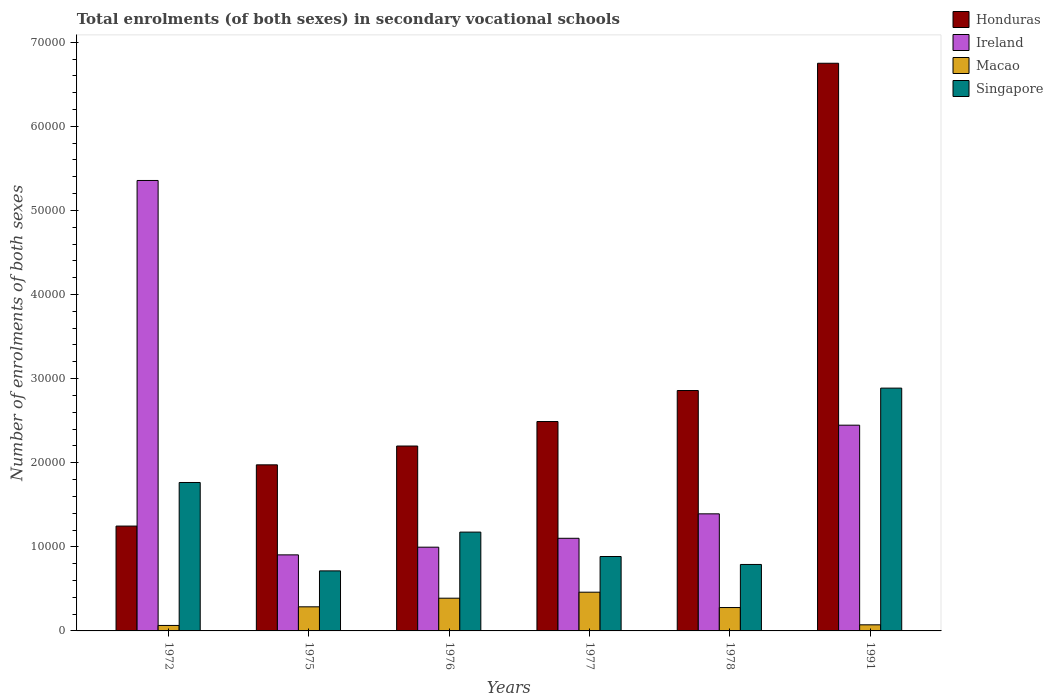How many different coloured bars are there?
Make the answer very short. 4. Are the number of bars per tick equal to the number of legend labels?
Offer a terse response. Yes. Are the number of bars on each tick of the X-axis equal?
Make the answer very short. Yes. How many bars are there on the 4th tick from the right?
Make the answer very short. 4. What is the number of enrolments in secondary schools in Macao in 1976?
Ensure brevity in your answer.  3891. Across all years, what is the maximum number of enrolments in secondary schools in Macao?
Ensure brevity in your answer.  4604. Across all years, what is the minimum number of enrolments in secondary schools in Macao?
Give a very brief answer. 652. In which year was the number of enrolments in secondary schools in Macao maximum?
Your answer should be compact. 1977. What is the total number of enrolments in secondary schools in Macao in the graph?
Offer a very short reply. 1.55e+04. What is the difference between the number of enrolments in secondary schools in Honduras in 1977 and that in 1978?
Provide a succinct answer. -3687. What is the difference between the number of enrolments in secondary schools in Singapore in 1976 and the number of enrolments in secondary schools in Honduras in 1972?
Provide a short and direct response. -717. What is the average number of enrolments in secondary schools in Singapore per year?
Offer a terse response. 1.37e+04. In the year 1975, what is the difference between the number of enrolments in secondary schools in Macao and number of enrolments in secondary schools in Ireland?
Offer a terse response. -6177. In how many years, is the number of enrolments in secondary schools in Honduras greater than 48000?
Your response must be concise. 1. What is the ratio of the number of enrolments in secondary schools in Macao in 1977 to that in 1978?
Keep it short and to the point. 1.66. What is the difference between the highest and the second highest number of enrolments in secondary schools in Macao?
Make the answer very short. 713. What is the difference between the highest and the lowest number of enrolments in secondary schools in Ireland?
Give a very brief answer. 4.45e+04. In how many years, is the number of enrolments in secondary schools in Singapore greater than the average number of enrolments in secondary schools in Singapore taken over all years?
Provide a succinct answer. 2. What does the 4th bar from the left in 1991 represents?
Your response must be concise. Singapore. What does the 2nd bar from the right in 1991 represents?
Ensure brevity in your answer.  Macao. Is it the case that in every year, the sum of the number of enrolments in secondary schools in Ireland and number of enrolments in secondary schools in Honduras is greater than the number of enrolments in secondary schools in Singapore?
Your answer should be very brief. Yes. Where does the legend appear in the graph?
Give a very brief answer. Top right. What is the title of the graph?
Offer a very short reply. Total enrolments (of both sexes) in secondary vocational schools. What is the label or title of the X-axis?
Give a very brief answer. Years. What is the label or title of the Y-axis?
Your answer should be very brief. Number of enrolments of both sexes. What is the Number of enrolments of both sexes of Honduras in 1972?
Offer a very short reply. 1.25e+04. What is the Number of enrolments of both sexes of Ireland in 1972?
Give a very brief answer. 5.36e+04. What is the Number of enrolments of both sexes of Macao in 1972?
Ensure brevity in your answer.  652. What is the Number of enrolments of both sexes in Singapore in 1972?
Your answer should be compact. 1.76e+04. What is the Number of enrolments of both sexes of Honduras in 1975?
Your response must be concise. 1.97e+04. What is the Number of enrolments of both sexes of Ireland in 1975?
Keep it short and to the point. 9043. What is the Number of enrolments of both sexes of Macao in 1975?
Ensure brevity in your answer.  2866. What is the Number of enrolments of both sexes in Singapore in 1975?
Ensure brevity in your answer.  7140. What is the Number of enrolments of both sexes of Honduras in 1976?
Your response must be concise. 2.20e+04. What is the Number of enrolments of both sexes in Ireland in 1976?
Keep it short and to the point. 9957. What is the Number of enrolments of both sexes of Macao in 1976?
Make the answer very short. 3891. What is the Number of enrolments of both sexes in Singapore in 1976?
Make the answer very short. 1.18e+04. What is the Number of enrolments of both sexes of Honduras in 1977?
Keep it short and to the point. 2.49e+04. What is the Number of enrolments of both sexes in Ireland in 1977?
Give a very brief answer. 1.10e+04. What is the Number of enrolments of both sexes of Macao in 1977?
Provide a succinct answer. 4604. What is the Number of enrolments of both sexes in Singapore in 1977?
Offer a terse response. 8848. What is the Number of enrolments of both sexes in Honduras in 1978?
Ensure brevity in your answer.  2.86e+04. What is the Number of enrolments of both sexes of Ireland in 1978?
Your answer should be compact. 1.39e+04. What is the Number of enrolments of both sexes of Macao in 1978?
Give a very brief answer. 2781. What is the Number of enrolments of both sexes in Singapore in 1978?
Your answer should be compact. 7902. What is the Number of enrolments of both sexes of Honduras in 1991?
Offer a terse response. 6.75e+04. What is the Number of enrolments of both sexes in Ireland in 1991?
Keep it short and to the point. 2.45e+04. What is the Number of enrolments of both sexes of Macao in 1991?
Make the answer very short. 725. What is the Number of enrolments of both sexes of Singapore in 1991?
Offer a terse response. 2.89e+04. Across all years, what is the maximum Number of enrolments of both sexes in Honduras?
Provide a short and direct response. 6.75e+04. Across all years, what is the maximum Number of enrolments of both sexes in Ireland?
Keep it short and to the point. 5.36e+04. Across all years, what is the maximum Number of enrolments of both sexes of Macao?
Your answer should be very brief. 4604. Across all years, what is the maximum Number of enrolments of both sexes of Singapore?
Your answer should be very brief. 2.89e+04. Across all years, what is the minimum Number of enrolments of both sexes in Honduras?
Keep it short and to the point. 1.25e+04. Across all years, what is the minimum Number of enrolments of both sexes in Ireland?
Ensure brevity in your answer.  9043. Across all years, what is the minimum Number of enrolments of both sexes of Macao?
Keep it short and to the point. 652. Across all years, what is the minimum Number of enrolments of both sexes in Singapore?
Provide a succinct answer. 7140. What is the total Number of enrolments of both sexes of Honduras in the graph?
Your answer should be very brief. 1.75e+05. What is the total Number of enrolments of both sexes in Ireland in the graph?
Offer a terse response. 1.22e+05. What is the total Number of enrolments of both sexes of Macao in the graph?
Ensure brevity in your answer.  1.55e+04. What is the total Number of enrolments of both sexes in Singapore in the graph?
Give a very brief answer. 8.22e+04. What is the difference between the Number of enrolments of both sexes in Honduras in 1972 and that in 1975?
Keep it short and to the point. -7281. What is the difference between the Number of enrolments of both sexes in Ireland in 1972 and that in 1975?
Your response must be concise. 4.45e+04. What is the difference between the Number of enrolments of both sexes in Macao in 1972 and that in 1975?
Ensure brevity in your answer.  -2214. What is the difference between the Number of enrolments of both sexes of Singapore in 1972 and that in 1975?
Offer a very short reply. 1.05e+04. What is the difference between the Number of enrolments of both sexes of Honduras in 1972 and that in 1976?
Offer a terse response. -9518. What is the difference between the Number of enrolments of both sexes of Ireland in 1972 and that in 1976?
Ensure brevity in your answer.  4.36e+04. What is the difference between the Number of enrolments of both sexes in Macao in 1972 and that in 1976?
Make the answer very short. -3239. What is the difference between the Number of enrolments of both sexes of Singapore in 1972 and that in 1976?
Your answer should be very brief. 5898. What is the difference between the Number of enrolments of both sexes in Honduras in 1972 and that in 1977?
Offer a terse response. -1.24e+04. What is the difference between the Number of enrolments of both sexes of Ireland in 1972 and that in 1977?
Offer a terse response. 4.25e+04. What is the difference between the Number of enrolments of both sexes in Macao in 1972 and that in 1977?
Make the answer very short. -3952. What is the difference between the Number of enrolments of both sexes in Singapore in 1972 and that in 1977?
Your answer should be compact. 8801. What is the difference between the Number of enrolments of both sexes of Honduras in 1972 and that in 1978?
Ensure brevity in your answer.  -1.61e+04. What is the difference between the Number of enrolments of both sexes in Ireland in 1972 and that in 1978?
Your answer should be compact. 3.96e+04. What is the difference between the Number of enrolments of both sexes of Macao in 1972 and that in 1978?
Your response must be concise. -2129. What is the difference between the Number of enrolments of both sexes in Singapore in 1972 and that in 1978?
Provide a succinct answer. 9747. What is the difference between the Number of enrolments of both sexes in Honduras in 1972 and that in 1991?
Your response must be concise. -5.50e+04. What is the difference between the Number of enrolments of both sexes in Ireland in 1972 and that in 1991?
Your response must be concise. 2.91e+04. What is the difference between the Number of enrolments of both sexes in Macao in 1972 and that in 1991?
Your response must be concise. -73. What is the difference between the Number of enrolments of both sexes of Singapore in 1972 and that in 1991?
Offer a very short reply. -1.12e+04. What is the difference between the Number of enrolments of both sexes in Honduras in 1975 and that in 1976?
Give a very brief answer. -2237. What is the difference between the Number of enrolments of both sexes of Ireland in 1975 and that in 1976?
Ensure brevity in your answer.  -914. What is the difference between the Number of enrolments of both sexes of Macao in 1975 and that in 1976?
Offer a very short reply. -1025. What is the difference between the Number of enrolments of both sexes in Singapore in 1975 and that in 1976?
Give a very brief answer. -4611. What is the difference between the Number of enrolments of both sexes in Honduras in 1975 and that in 1977?
Keep it short and to the point. -5150. What is the difference between the Number of enrolments of both sexes of Ireland in 1975 and that in 1977?
Your answer should be compact. -1972. What is the difference between the Number of enrolments of both sexes in Macao in 1975 and that in 1977?
Offer a very short reply. -1738. What is the difference between the Number of enrolments of both sexes in Singapore in 1975 and that in 1977?
Your answer should be very brief. -1708. What is the difference between the Number of enrolments of both sexes in Honduras in 1975 and that in 1978?
Your response must be concise. -8837. What is the difference between the Number of enrolments of both sexes of Ireland in 1975 and that in 1978?
Give a very brief answer. -4879. What is the difference between the Number of enrolments of both sexes of Macao in 1975 and that in 1978?
Your answer should be very brief. 85. What is the difference between the Number of enrolments of both sexes of Singapore in 1975 and that in 1978?
Provide a short and direct response. -762. What is the difference between the Number of enrolments of both sexes of Honduras in 1975 and that in 1991?
Ensure brevity in your answer.  -4.78e+04. What is the difference between the Number of enrolments of both sexes of Ireland in 1975 and that in 1991?
Give a very brief answer. -1.54e+04. What is the difference between the Number of enrolments of both sexes in Macao in 1975 and that in 1991?
Make the answer very short. 2141. What is the difference between the Number of enrolments of both sexes in Singapore in 1975 and that in 1991?
Make the answer very short. -2.17e+04. What is the difference between the Number of enrolments of both sexes of Honduras in 1976 and that in 1977?
Give a very brief answer. -2913. What is the difference between the Number of enrolments of both sexes of Ireland in 1976 and that in 1977?
Offer a terse response. -1058. What is the difference between the Number of enrolments of both sexes in Macao in 1976 and that in 1977?
Your answer should be very brief. -713. What is the difference between the Number of enrolments of both sexes in Singapore in 1976 and that in 1977?
Your answer should be compact. 2903. What is the difference between the Number of enrolments of both sexes of Honduras in 1976 and that in 1978?
Your answer should be very brief. -6600. What is the difference between the Number of enrolments of both sexes of Ireland in 1976 and that in 1978?
Ensure brevity in your answer.  -3965. What is the difference between the Number of enrolments of both sexes in Macao in 1976 and that in 1978?
Give a very brief answer. 1110. What is the difference between the Number of enrolments of both sexes in Singapore in 1976 and that in 1978?
Your answer should be very brief. 3849. What is the difference between the Number of enrolments of both sexes of Honduras in 1976 and that in 1991?
Your answer should be very brief. -4.55e+04. What is the difference between the Number of enrolments of both sexes in Ireland in 1976 and that in 1991?
Provide a succinct answer. -1.45e+04. What is the difference between the Number of enrolments of both sexes of Macao in 1976 and that in 1991?
Your answer should be very brief. 3166. What is the difference between the Number of enrolments of both sexes of Singapore in 1976 and that in 1991?
Give a very brief answer. -1.71e+04. What is the difference between the Number of enrolments of both sexes of Honduras in 1977 and that in 1978?
Give a very brief answer. -3687. What is the difference between the Number of enrolments of both sexes of Ireland in 1977 and that in 1978?
Provide a short and direct response. -2907. What is the difference between the Number of enrolments of both sexes of Macao in 1977 and that in 1978?
Your answer should be compact. 1823. What is the difference between the Number of enrolments of both sexes of Singapore in 1977 and that in 1978?
Your response must be concise. 946. What is the difference between the Number of enrolments of both sexes in Honduras in 1977 and that in 1991?
Keep it short and to the point. -4.26e+04. What is the difference between the Number of enrolments of both sexes in Ireland in 1977 and that in 1991?
Ensure brevity in your answer.  -1.34e+04. What is the difference between the Number of enrolments of both sexes in Macao in 1977 and that in 1991?
Offer a terse response. 3879. What is the difference between the Number of enrolments of both sexes of Singapore in 1977 and that in 1991?
Make the answer very short. -2.00e+04. What is the difference between the Number of enrolments of both sexes of Honduras in 1978 and that in 1991?
Ensure brevity in your answer.  -3.89e+04. What is the difference between the Number of enrolments of both sexes in Ireland in 1978 and that in 1991?
Provide a short and direct response. -1.05e+04. What is the difference between the Number of enrolments of both sexes in Macao in 1978 and that in 1991?
Offer a very short reply. 2056. What is the difference between the Number of enrolments of both sexes of Singapore in 1978 and that in 1991?
Give a very brief answer. -2.10e+04. What is the difference between the Number of enrolments of both sexes in Honduras in 1972 and the Number of enrolments of both sexes in Ireland in 1975?
Provide a short and direct response. 3425. What is the difference between the Number of enrolments of both sexes of Honduras in 1972 and the Number of enrolments of both sexes of Macao in 1975?
Your response must be concise. 9602. What is the difference between the Number of enrolments of both sexes in Honduras in 1972 and the Number of enrolments of both sexes in Singapore in 1975?
Give a very brief answer. 5328. What is the difference between the Number of enrolments of both sexes of Ireland in 1972 and the Number of enrolments of both sexes of Macao in 1975?
Ensure brevity in your answer.  5.07e+04. What is the difference between the Number of enrolments of both sexes in Ireland in 1972 and the Number of enrolments of both sexes in Singapore in 1975?
Offer a very short reply. 4.64e+04. What is the difference between the Number of enrolments of both sexes of Macao in 1972 and the Number of enrolments of both sexes of Singapore in 1975?
Provide a succinct answer. -6488. What is the difference between the Number of enrolments of both sexes of Honduras in 1972 and the Number of enrolments of both sexes of Ireland in 1976?
Offer a very short reply. 2511. What is the difference between the Number of enrolments of both sexes in Honduras in 1972 and the Number of enrolments of both sexes in Macao in 1976?
Make the answer very short. 8577. What is the difference between the Number of enrolments of both sexes of Honduras in 1972 and the Number of enrolments of both sexes of Singapore in 1976?
Offer a very short reply. 717. What is the difference between the Number of enrolments of both sexes of Ireland in 1972 and the Number of enrolments of both sexes of Macao in 1976?
Your answer should be compact. 4.97e+04. What is the difference between the Number of enrolments of both sexes in Ireland in 1972 and the Number of enrolments of both sexes in Singapore in 1976?
Ensure brevity in your answer.  4.18e+04. What is the difference between the Number of enrolments of both sexes of Macao in 1972 and the Number of enrolments of both sexes of Singapore in 1976?
Offer a very short reply. -1.11e+04. What is the difference between the Number of enrolments of both sexes of Honduras in 1972 and the Number of enrolments of both sexes of Ireland in 1977?
Offer a terse response. 1453. What is the difference between the Number of enrolments of both sexes in Honduras in 1972 and the Number of enrolments of both sexes in Macao in 1977?
Offer a terse response. 7864. What is the difference between the Number of enrolments of both sexes in Honduras in 1972 and the Number of enrolments of both sexes in Singapore in 1977?
Your answer should be very brief. 3620. What is the difference between the Number of enrolments of both sexes of Ireland in 1972 and the Number of enrolments of both sexes of Macao in 1977?
Keep it short and to the point. 4.90e+04. What is the difference between the Number of enrolments of both sexes of Ireland in 1972 and the Number of enrolments of both sexes of Singapore in 1977?
Keep it short and to the point. 4.47e+04. What is the difference between the Number of enrolments of both sexes of Macao in 1972 and the Number of enrolments of both sexes of Singapore in 1977?
Your answer should be compact. -8196. What is the difference between the Number of enrolments of both sexes in Honduras in 1972 and the Number of enrolments of both sexes in Ireland in 1978?
Provide a short and direct response. -1454. What is the difference between the Number of enrolments of both sexes in Honduras in 1972 and the Number of enrolments of both sexes in Macao in 1978?
Provide a short and direct response. 9687. What is the difference between the Number of enrolments of both sexes in Honduras in 1972 and the Number of enrolments of both sexes in Singapore in 1978?
Your answer should be compact. 4566. What is the difference between the Number of enrolments of both sexes in Ireland in 1972 and the Number of enrolments of both sexes in Macao in 1978?
Offer a very short reply. 5.08e+04. What is the difference between the Number of enrolments of both sexes in Ireland in 1972 and the Number of enrolments of both sexes in Singapore in 1978?
Offer a terse response. 4.57e+04. What is the difference between the Number of enrolments of both sexes in Macao in 1972 and the Number of enrolments of both sexes in Singapore in 1978?
Provide a short and direct response. -7250. What is the difference between the Number of enrolments of both sexes of Honduras in 1972 and the Number of enrolments of both sexes of Ireland in 1991?
Ensure brevity in your answer.  -1.20e+04. What is the difference between the Number of enrolments of both sexes of Honduras in 1972 and the Number of enrolments of both sexes of Macao in 1991?
Offer a very short reply. 1.17e+04. What is the difference between the Number of enrolments of both sexes in Honduras in 1972 and the Number of enrolments of both sexes in Singapore in 1991?
Your response must be concise. -1.64e+04. What is the difference between the Number of enrolments of both sexes of Ireland in 1972 and the Number of enrolments of both sexes of Macao in 1991?
Your answer should be compact. 5.28e+04. What is the difference between the Number of enrolments of both sexes of Ireland in 1972 and the Number of enrolments of both sexes of Singapore in 1991?
Provide a short and direct response. 2.47e+04. What is the difference between the Number of enrolments of both sexes of Macao in 1972 and the Number of enrolments of both sexes of Singapore in 1991?
Your response must be concise. -2.82e+04. What is the difference between the Number of enrolments of both sexes in Honduras in 1975 and the Number of enrolments of both sexes in Ireland in 1976?
Give a very brief answer. 9792. What is the difference between the Number of enrolments of both sexes in Honduras in 1975 and the Number of enrolments of both sexes in Macao in 1976?
Offer a very short reply. 1.59e+04. What is the difference between the Number of enrolments of both sexes in Honduras in 1975 and the Number of enrolments of both sexes in Singapore in 1976?
Keep it short and to the point. 7998. What is the difference between the Number of enrolments of both sexes of Ireland in 1975 and the Number of enrolments of both sexes of Macao in 1976?
Offer a very short reply. 5152. What is the difference between the Number of enrolments of both sexes in Ireland in 1975 and the Number of enrolments of both sexes in Singapore in 1976?
Provide a short and direct response. -2708. What is the difference between the Number of enrolments of both sexes in Macao in 1975 and the Number of enrolments of both sexes in Singapore in 1976?
Provide a succinct answer. -8885. What is the difference between the Number of enrolments of both sexes in Honduras in 1975 and the Number of enrolments of both sexes in Ireland in 1977?
Your answer should be compact. 8734. What is the difference between the Number of enrolments of both sexes in Honduras in 1975 and the Number of enrolments of both sexes in Macao in 1977?
Offer a terse response. 1.51e+04. What is the difference between the Number of enrolments of both sexes of Honduras in 1975 and the Number of enrolments of both sexes of Singapore in 1977?
Your response must be concise. 1.09e+04. What is the difference between the Number of enrolments of both sexes of Ireland in 1975 and the Number of enrolments of both sexes of Macao in 1977?
Your answer should be compact. 4439. What is the difference between the Number of enrolments of both sexes in Ireland in 1975 and the Number of enrolments of both sexes in Singapore in 1977?
Keep it short and to the point. 195. What is the difference between the Number of enrolments of both sexes in Macao in 1975 and the Number of enrolments of both sexes in Singapore in 1977?
Offer a terse response. -5982. What is the difference between the Number of enrolments of both sexes of Honduras in 1975 and the Number of enrolments of both sexes of Ireland in 1978?
Provide a short and direct response. 5827. What is the difference between the Number of enrolments of both sexes in Honduras in 1975 and the Number of enrolments of both sexes in Macao in 1978?
Offer a terse response. 1.70e+04. What is the difference between the Number of enrolments of both sexes in Honduras in 1975 and the Number of enrolments of both sexes in Singapore in 1978?
Give a very brief answer. 1.18e+04. What is the difference between the Number of enrolments of both sexes in Ireland in 1975 and the Number of enrolments of both sexes in Macao in 1978?
Offer a terse response. 6262. What is the difference between the Number of enrolments of both sexes in Ireland in 1975 and the Number of enrolments of both sexes in Singapore in 1978?
Your answer should be very brief. 1141. What is the difference between the Number of enrolments of both sexes in Macao in 1975 and the Number of enrolments of both sexes in Singapore in 1978?
Make the answer very short. -5036. What is the difference between the Number of enrolments of both sexes in Honduras in 1975 and the Number of enrolments of both sexes in Ireland in 1991?
Your response must be concise. -4715. What is the difference between the Number of enrolments of both sexes in Honduras in 1975 and the Number of enrolments of both sexes in Macao in 1991?
Give a very brief answer. 1.90e+04. What is the difference between the Number of enrolments of both sexes of Honduras in 1975 and the Number of enrolments of both sexes of Singapore in 1991?
Provide a succinct answer. -9122. What is the difference between the Number of enrolments of both sexes of Ireland in 1975 and the Number of enrolments of both sexes of Macao in 1991?
Provide a succinct answer. 8318. What is the difference between the Number of enrolments of both sexes in Ireland in 1975 and the Number of enrolments of both sexes in Singapore in 1991?
Keep it short and to the point. -1.98e+04. What is the difference between the Number of enrolments of both sexes in Macao in 1975 and the Number of enrolments of both sexes in Singapore in 1991?
Your response must be concise. -2.60e+04. What is the difference between the Number of enrolments of both sexes of Honduras in 1976 and the Number of enrolments of both sexes of Ireland in 1977?
Offer a very short reply. 1.10e+04. What is the difference between the Number of enrolments of both sexes of Honduras in 1976 and the Number of enrolments of both sexes of Macao in 1977?
Keep it short and to the point. 1.74e+04. What is the difference between the Number of enrolments of both sexes in Honduras in 1976 and the Number of enrolments of both sexes in Singapore in 1977?
Keep it short and to the point. 1.31e+04. What is the difference between the Number of enrolments of both sexes of Ireland in 1976 and the Number of enrolments of both sexes of Macao in 1977?
Make the answer very short. 5353. What is the difference between the Number of enrolments of both sexes in Ireland in 1976 and the Number of enrolments of both sexes in Singapore in 1977?
Offer a very short reply. 1109. What is the difference between the Number of enrolments of both sexes in Macao in 1976 and the Number of enrolments of both sexes in Singapore in 1977?
Your answer should be very brief. -4957. What is the difference between the Number of enrolments of both sexes of Honduras in 1976 and the Number of enrolments of both sexes of Ireland in 1978?
Your response must be concise. 8064. What is the difference between the Number of enrolments of both sexes of Honduras in 1976 and the Number of enrolments of both sexes of Macao in 1978?
Provide a short and direct response. 1.92e+04. What is the difference between the Number of enrolments of both sexes of Honduras in 1976 and the Number of enrolments of both sexes of Singapore in 1978?
Keep it short and to the point. 1.41e+04. What is the difference between the Number of enrolments of both sexes of Ireland in 1976 and the Number of enrolments of both sexes of Macao in 1978?
Make the answer very short. 7176. What is the difference between the Number of enrolments of both sexes of Ireland in 1976 and the Number of enrolments of both sexes of Singapore in 1978?
Your response must be concise. 2055. What is the difference between the Number of enrolments of both sexes in Macao in 1976 and the Number of enrolments of both sexes in Singapore in 1978?
Your answer should be compact. -4011. What is the difference between the Number of enrolments of both sexes in Honduras in 1976 and the Number of enrolments of both sexes in Ireland in 1991?
Offer a terse response. -2478. What is the difference between the Number of enrolments of both sexes of Honduras in 1976 and the Number of enrolments of both sexes of Macao in 1991?
Your response must be concise. 2.13e+04. What is the difference between the Number of enrolments of both sexes of Honduras in 1976 and the Number of enrolments of both sexes of Singapore in 1991?
Ensure brevity in your answer.  -6885. What is the difference between the Number of enrolments of both sexes of Ireland in 1976 and the Number of enrolments of both sexes of Macao in 1991?
Make the answer very short. 9232. What is the difference between the Number of enrolments of both sexes in Ireland in 1976 and the Number of enrolments of both sexes in Singapore in 1991?
Keep it short and to the point. -1.89e+04. What is the difference between the Number of enrolments of both sexes in Macao in 1976 and the Number of enrolments of both sexes in Singapore in 1991?
Your response must be concise. -2.50e+04. What is the difference between the Number of enrolments of both sexes in Honduras in 1977 and the Number of enrolments of both sexes in Ireland in 1978?
Your answer should be very brief. 1.10e+04. What is the difference between the Number of enrolments of both sexes of Honduras in 1977 and the Number of enrolments of both sexes of Macao in 1978?
Your answer should be compact. 2.21e+04. What is the difference between the Number of enrolments of both sexes of Honduras in 1977 and the Number of enrolments of both sexes of Singapore in 1978?
Provide a succinct answer. 1.70e+04. What is the difference between the Number of enrolments of both sexes of Ireland in 1977 and the Number of enrolments of both sexes of Macao in 1978?
Ensure brevity in your answer.  8234. What is the difference between the Number of enrolments of both sexes of Ireland in 1977 and the Number of enrolments of both sexes of Singapore in 1978?
Make the answer very short. 3113. What is the difference between the Number of enrolments of both sexes in Macao in 1977 and the Number of enrolments of both sexes in Singapore in 1978?
Give a very brief answer. -3298. What is the difference between the Number of enrolments of both sexes in Honduras in 1977 and the Number of enrolments of both sexes in Ireland in 1991?
Keep it short and to the point. 435. What is the difference between the Number of enrolments of both sexes in Honduras in 1977 and the Number of enrolments of both sexes in Macao in 1991?
Offer a terse response. 2.42e+04. What is the difference between the Number of enrolments of both sexes of Honduras in 1977 and the Number of enrolments of both sexes of Singapore in 1991?
Give a very brief answer. -3972. What is the difference between the Number of enrolments of both sexes in Ireland in 1977 and the Number of enrolments of both sexes in Macao in 1991?
Your response must be concise. 1.03e+04. What is the difference between the Number of enrolments of both sexes in Ireland in 1977 and the Number of enrolments of both sexes in Singapore in 1991?
Your answer should be compact. -1.79e+04. What is the difference between the Number of enrolments of both sexes in Macao in 1977 and the Number of enrolments of both sexes in Singapore in 1991?
Your answer should be compact. -2.43e+04. What is the difference between the Number of enrolments of both sexes in Honduras in 1978 and the Number of enrolments of both sexes in Ireland in 1991?
Provide a succinct answer. 4122. What is the difference between the Number of enrolments of both sexes in Honduras in 1978 and the Number of enrolments of both sexes in Macao in 1991?
Ensure brevity in your answer.  2.79e+04. What is the difference between the Number of enrolments of both sexes in Honduras in 1978 and the Number of enrolments of both sexes in Singapore in 1991?
Your response must be concise. -285. What is the difference between the Number of enrolments of both sexes in Ireland in 1978 and the Number of enrolments of both sexes in Macao in 1991?
Your response must be concise. 1.32e+04. What is the difference between the Number of enrolments of both sexes of Ireland in 1978 and the Number of enrolments of both sexes of Singapore in 1991?
Give a very brief answer. -1.49e+04. What is the difference between the Number of enrolments of both sexes of Macao in 1978 and the Number of enrolments of both sexes of Singapore in 1991?
Give a very brief answer. -2.61e+04. What is the average Number of enrolments of both sexes of Honduras per year?
Ensure brevity in your answer.  2.92e+04. What is the average Number of enrolments of both sexes in Ireland per year?
Your answer should be very brief. 2.03e+04. What is the average Number of enrolments of both sexes in Macao per year?
Offer a terse response. 2586.5. What is the average Number of enrolments of both sexes in Singapore per year?
Offer a terse response. 1.37e+04. In the year 1972, what is the difference between the Number of enrolments of both sexes in Honduras and Number of enrolments of both sexes in Ireland?
Your response must be concise. -4.11e+04. In the year 1972, what is the difference between the Number of enrolments of both sexes of Honduras and Number of enrolments of both sexes of Macao?
Give a very brief answer. 1.18e+04. In the year 1972, what is the difference between the Number of enrolments of both sexes in Honduras and Number of enrolments of both sexes in Singapore?
Provide a succinct answer. -5181. In the year 1972, what is the difference between the Number of enrolments of both sexes in Ireland and Number of enrolments of both sexes in Macao?
Offer a terse response. 5.29e+04. In the year 1972, what is the difference between the Number of enrolments of both sexes of Ireland and Number of enrolments of both sexes of Singapore?
Provide a succinct answer. 3.59e+04. In the year 1972, what is the difference between the Number of enrolments of both sexes in Macao and Number of enrolments of both sexes in Singapore?
Provide a succinct answer. -1.70e+04. In the year 1975, what is the difference between the Number of enrolments of both sexes in Honduras and Number of enrolments of both sexes in Ireland?
Your answer should be very brief. 1.07e+04. In the year 1975, what is the difference between the Number of enrolments of both sexes in Honduras and Number of enrolments of both sexes in Macao?
Give a very brief answer. 1.69e+04. In the year 1975, what is the difference between the Number of enrolments of both sexes of Honduras and Number of enrolments of both sexes of Singapore?
Offer a very short reply. 1.26e+04. In the year 1975, what is the difference between the Number of enrolments of both sexes of Ireland and Number of enrolments of both sexes of Macao?
Ensure brevity in your answer.  6177. In the year 1975, what is the difference between the Number of enrolments of both sexes in Ireland and Number of enrolments of both sexes in Singapore?
Your answer should be very brief. 1903. In the year 1975, what is the difference between the Number of enrolments of both sexes of Macao and Number of enrolments of both sexes of Singapore?
Ensure brevity in your answer.  -4274. In the year 1976, what is the difference between the Number of enrolments of both sexes in Honduras and Number of enrolments of both sexes in Ireland?
Give a very brief answer. 1.20e+04. In the year 1976, what is the difference between the Number of enrolments of both sexes of Honduras and Number of enrolments of both sexes of Macao?
Give a very brief answer. 1.81e+04. In the year 1976, what is the difference between the Number of enrolments of both sexes in Honduras and Number of enrolments of both sexes in Singapore?
Keep it short and to the point. 1.02e+04. In the year 1976, what is the difference between the Number of enrolments of both sexes of Ireland and Number of enrolments of both sexes of Macao?
Give a very brief answer. 6066. In the year 1976, what is the difference between the Number of enrolments of both sexes in Ireland and Number of enrolments of both sexes in Singapore?
Your response must be concise. -1794. In the year 1976, what is the difference between the Number of enrolments of both sexes in Macao and Number of enrolments of both sexes in Singapore?
Offer a terse response. -7860. In the year 1977, what is the difference between the Number of enrolments of both sexes in Honduras and Number of enrolments of both sexes in Ireland?
Your response must be concise. 1.39e+04. In the year 1977, what is the difference between the Number of enrolments of both sexes of Honduras and Number of enrolments of both sexes of Macao?
Make the answer very short. 2.03e+04. In the year 1977, what is the difference between the Number of enrolments of both sexes of Honduras and Number of enrolments of both sexes of Singapore?
Give a very brief answer. 1.61e+04. In the year 1977, what is the difference between the Number of enrolments of both sexes of Ireland and Number of enrolments of both sexes of Macao?
Your response must be concise. 6411. In the year 1977, what is the difference between the Number of enrolments of both sexes of Ireland and Number of enrolments of both sexes of Singapore?
Provide a succinct answer. 2167. In the year 1977, what is the difference between the Number of enrolments of both sexes of Macao and Number of enrolments of both sexes of Singapore?
Make the answer very short. -4244. In the year 1978, what is the difference between the Number of enrolments of both sexes in Honduras and Number of enrolments of both sexes in Ireland?
Make the answer very short. 1.47e+04. In the year 1978, what is the difference between the Number of enrolments of both sexes of Honduras and Number of enrolments of both sexes of Macao?
Provide a succinct answer. 2.58e+04. In the year 1978, what is the difference between the Number of enrolments of both sexes in Honduras and Number of enrolments of both sexes in Singapore?
Your answer should be compact. 2.07e+04. In the year 1978, what is the difference between the Number of enrolments of both sexes of Ireland and Number of enrolments of both sexes of Macao?
Your answer should be compact. 1.11e+04. In the year 1978, what is the difference between the Number of enrolments of both sexes of Ireland and Number of enrolments of both sexes of Singapore?
Keep it short and to the point. 6020. In the year 1978, what is the difference between the Number of enrolments of both sexes of Macao and Number of enrolments of both sexes of Singapore?
Offer a terse response. -5121. In the year 1991, what is the difference between the Number of enrolments of both sexes of Honduras and Number of enrolments of both sexes of Ireland?
Provide a succinct answer. 4.30e+04. In the year 1991, what is the difference between the Number of enrolments of both sexes in Honduras and Number of enrolments of both sexes in Macao?
Give a very brief answer. 6.68e+04. In the year 1991, what is the difference between the Number of enrolments of both sexes of Honduras and Number of enrolments of both sexes of Singapore?
Offer a very short reply. 3.86e+04. In the year 1991, what is the difference between the Number of enrolments of both sexes in Ireland and Number of enrolments of both sexes in Macao?
Make the answer very short. 2.37e+04. In the year 1991, what is the difference between the Number of enrolments of both sexes of Ireland and Number of enrolments of both sexes of Singapore?
Make the answer very short. -4407. In the year 1991, what is the difference between the Number of enrolments of both sexes in Macao and Number of enrolments of both sexes in Singapore?
Provide a short and direct response. -2.81e+04. What is the ratio of the Number of enrolments of both sexes of Honduras in 1972 to that in 1975?
Your answer should be compact. 0.63. What is the ratio of the Number of enrolments of both sexes of Ireland in 1972 to that in 1975?
Keep it short and to the point. 5.92. What is the ratio of the Number of enrolments of both sexes of Macao in 1972 to that in 1975?
Your answer should be compact. 0.23. What is the ratio of the Number of enrolments of both sexes of Singapore in 1972 to that in 1975?
Your answer should be very brief. 2.47. What is the ratio of the Number of enrolments of both sexes of Honduras in 1972 to that in 1976?
Keep it short and to the point. 0.57. What is the ratio of the Number of enrolments of both sexes in Ireland in 1972 to that in 1976?
Ensure brevity in your answer.  5.38. What is the ratio of the Number of enrolments of both sexes of Macao in 1972 to that in 1976?
Your response must be concise. 0.17. What is the ratio of the Number of enrolments of both sexes in Singapore in 1972 to that in 1976?
Offer a very short reply. 1.5. What is the ratio of the Number of enrolments of both sexes of Honduras in 1972 to that in 1977?
Your answer should be very brief. 0.5. What is the ratio of the Number of enrolments of both sexes in Ireland in 1972 to that in 1977?
Provide a short and direct response. 4.86. What is the ratio of the Number of enrolments of both sexes in Macao in 1972 to that in 1977?
Offer a very short reply. 0.14. What is the ratio of the Number of enrolments of both sexes in Singapore in 1972 to that in 1977?
Ensure brevity in your answer.  1.99. What is the ratio of the Number of enrolments of both sexes in Honduras in 1972 to that in 1978?
Ensure brevity in your answer.  0.44. What is the ratio of the Number of enrolments of both sexes in Ireland in 1972 to that in 1978?
Provide a succinct answer. 3.85. What is the ratio of the Number of enrolments of both sexes of Macao in 1972 to that in 1978?
Offer a very short reply. 0.23. What is the ratio of the Number of enrolments of both sexes in Singapore in 1972 to that in 1978?
Offer a terse response. 2.23. What is the ratio of the Number of enrolments of both sexes of Honduras in 1972 to that in 1991?
Provide a succinct answer. 0.18. What is the ratio of the Number of enrolments of both sexes of Ireland in 1972 to that in 1991?
Keep it short and to the point. 2.19. What is the ratio of the Number of enrolments of both sexes in Macao in 1972 to that in 1991?
Offer a very short reply. 0.9. What is the ratio of the Number of enrolments of both sexes in Singapore in 1972 to that in 1991?
Your answer should be very brief. 0.61. What is the ratio of the Number of enrolments of both sexes of Honduras in 1975 to that in 1976?
Keep it short and to the point. 0.9. What is the ratio of the Number of enrolments of both sexes of Ireland in 1975 to that in 1976?
Ensure brevity in your answer.  0.91. What is the ratio of the Number of enrolments of both sexes in Macao in 1975 to that in 1976?
Offer a very short reply. 0.74. What is the ratio of the Number of enrolments of both sexes of Singapore in 1975 to that in 1976?
Your response must be concise. 0.61. What is the ratio of the Number of enrolments of both sexes in Honduras in 1975 to that in 1977?
Keep it short and to the point. 0.79. What is the ratio of the Number of enrolments of both sexes in Ireland in 1975 to that in 1977?
Make the answer very short. 0.82. What is the ratio of the Number of enrolments of both sexes in Macao in 1975 to that in 1977?
Your answer should be very brief. 0.62. What is the ratio of the Number of enrolments of both sexes of Singapore in 1975 to that in 1977?
Provide a short and direct response. 0.81. What is the ratio of the Number of enrolments of both sexes in Honduras in 1975 to that in 1978?
Offer a terse response. 0.69. What is the ratio of the Number of enrolments of both sexes in Ireland in 1975 to that in 1978?
Provide a succinct answer. 0.65. What is the ratio of the Number of enrolments of both sexes of Macao in 1975 to that in 1978?
Make the answer very short. 1.03. What is the ratio of the Number of enrolments of both sexes of Singapore in 1975 to that in 1978?
Offer a terse response. 0.9. What is the ratio of the Number of enrolments of both sexes in Honduras in 1975 to that in 1991?
Provide a short and direct response. 0.29. What is the ratio of the Number of enrolments of both sexes in Ireland in 1975 to that in 1991?
Ensure brevity in your answer.  0.37. What is the ratio of the Number of enrolments of both sexes of Macao in 1975 to that in 1991?
Your answer should be compact. 3.95. What is the ratio of the Number of enrolments of both sexes in Singapore in 1975 to that in 1991?
Provide a short and direct response. 0.25. What is the ratio of the Number of enrolments of both sexes in Honduras in 1976 to that in 1977?
Your answer should be compact. 0.88. What is the ratio of the Number of enrolments of both sexes in Ireland in 1976 to that in 1977?
Keep it short and to the point. 0.9. What is the ratio of the Number of enrolments of both sexes of Macao in 1976 to that in 1977?
Give a very brief answer. 0.85. What is the ratio of the Number of enrolments of both sexes of Singapore in 1976 to that in 1977?
Make the answer very short. 1.33. What is the ratio of the Number of enrolments of both sexes in Honduras in 1976 to that in 1978?
Provide a short and direct response. 0.77. What is the ratio of the Number of enrolments of both sexes in Ireland in 1976 to that in 1978?
Offer a very short reply. 0.72. What is the ratio of the Number of enrolments of both sexes of Macao in 1976 to that in 1978?
Make the answer very short. 1.4. What is the ratio of the Number of enrolments of both sexes in Singapore in 1976 to that in 1978?
Your answer should be compact. 1.49. What is the ratio of the Number of enrolments of both sexes of Honduras in 1976 to that in 1991?
Ensure brevity in your answer.  0.33. What is the ratio of the Number of enrolments of both sexes in Ireland in 1976 to that in 1991?
Provide a short and direct response. 0.41. What is the ratio of the Number of enrolments of both sexes of Macao in 1976 to that in 1991?
Keep it short and to the point. 5.37. What is the ratio of the Number of enrolments of both sexes in Singapore in 1976 to that in 1991?
Your answer should be compact. 0.41. What is the ratio of the Number of enrolments of both sexes in Honduras in 1977 to that in 1978?
Offer a very short reply. 0.87. What is the ratio of the Number of enrolments of both sexes of Ireland in 1977 to that in 1978?
Your answer should be compact. 0.79. What is the ratio of the Number of enrolments of both sexes in Macao in 1977 to that in 1978?
Keep it short and to the point. 1.66. What is the ratio of the Number of enrolments of both sexes in Singapore in 1977 to that in 1978?
Ensure brevity in your answer.  1.12. What is the ratio of the Number of enrolments of both sexes of Honduras in 1977 to that in 1991?
Your response must be concise. 0.37. What is the ratio of the Number of enrolments of both sexes of Ireland in 1977 to that in 1991?
Provide a succinct answer. 0.45. What is the ratio of the Number of enrolments of both sexes in Macao in 1977 to that in 1991?
Give a very brief answer. 6.35. What is the ratio of the Number of enrolments of both sexes of Singapore in 1977 to that in 1991?
Offer a very short reply. 0.31. What is the ratio of the Number of enrolments of both sexes in Honduras in 1978 to that in 1991?
Your answer should be compact. 0.42. What is the ratio of the Number of enrolments of both sexes in Ireland in 1978 to that in 1991?
Make the answer very short. 0.57. What is the ratio of the Number of enrolments of both sexes in Macao in 1978 to that in 1991?
Provide a succinct answer. 3.84. What is the ratio of the Number of enrolments of both sexes of Singapore in 1978 to that in 1991?
Your answer should be compact. 0.27. What is the difference between the highest and the second highest Number of enrolments of both sexes in Honduras?
Provide a succinct answer. 3.89e+04. What is the difference between the highest and the second highest Number of enrolments of both sexes in Ireland?
Ensure brevity in your answer.  2.91e+04. What is the difference between the highest and the second highest Number of enrolments of both sexes in Macao?
Make the answer very short. 713. What is the difference between the highest and the second highest Number of enrolments of both sexes of Singapore?
Provide a short and direct response. 1.12e+04. What is the difference between the highest and the lowest Number of enrolments of both sexes of Honduras?
Your response must be concise. 5.50e+04. What is the difference between the highest and the lowest Number of enrolments of both sexes in Ireland?
Your answer should be compact. 4.45e+04. What is the difference between the highest and the lowest Number of enrolments of both sexes in Macao?
Provide a short and direct response. 3952. What is the difference between the highest and the lowest Number of enrolments of both sexes in Singapore?
Offer a terse response. 2.17e+04. 